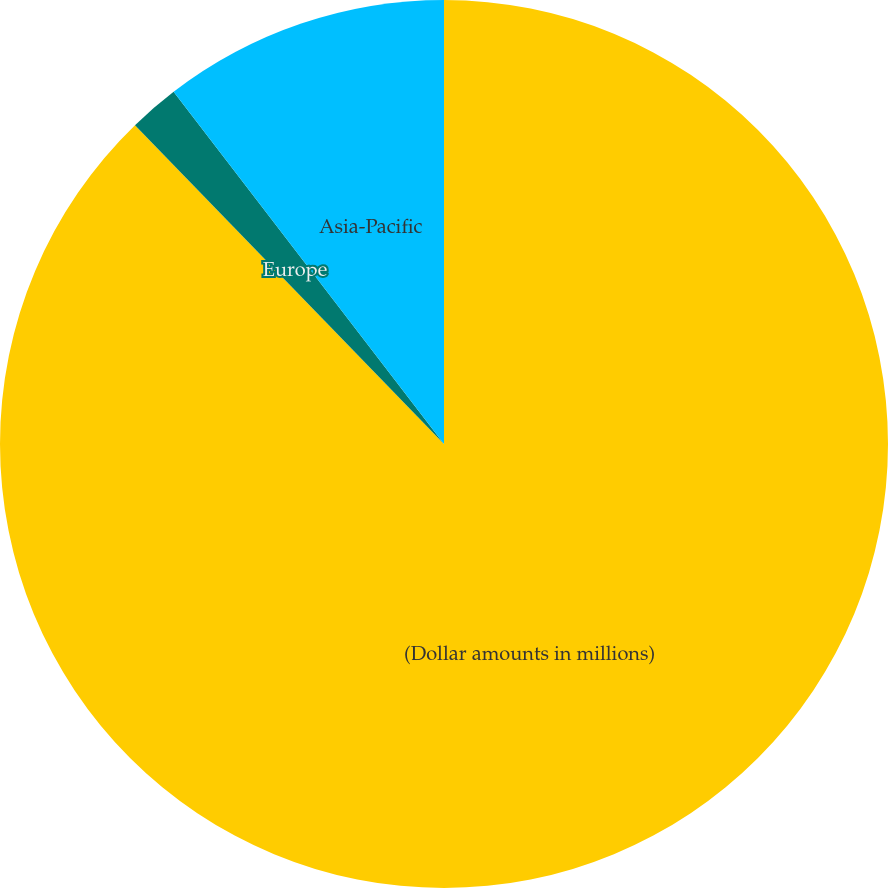Convert chart. <chart><loc_0><loc_0><loc_500><loc_500><pie_chart><fcel>(Dollar amounts in millions)<fcel>Europe<fcel>Asia-Pacific<nl><fcel>87.74%<fcel>1.83%<fcel>10.42%<nl></chart> 